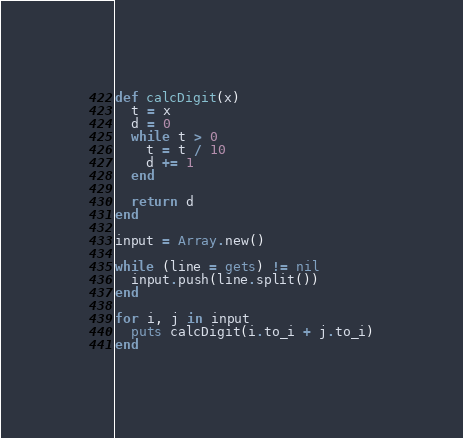<code> <loc_0><loc_0><loc_500><loc_500><_Ruby_>def calcDigit(x)
  t = x
  d = 0
  while t > 0
    t = t / 10
    d += 1
  end

  return d
end

input = Array.new()

while (line = gets) != nil
  input.push(line.split())
end

for i, j in input
  puts calcDigit(i.to_i + j.to_i)
end</code> 